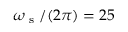<formula> <loc_0><loc_0><loc_500><loc_500>\omega _ { s } / ( 2 \pi ) = 2 5</formula> 